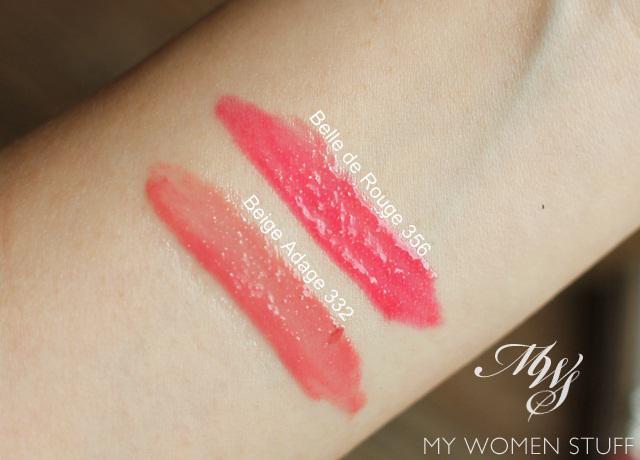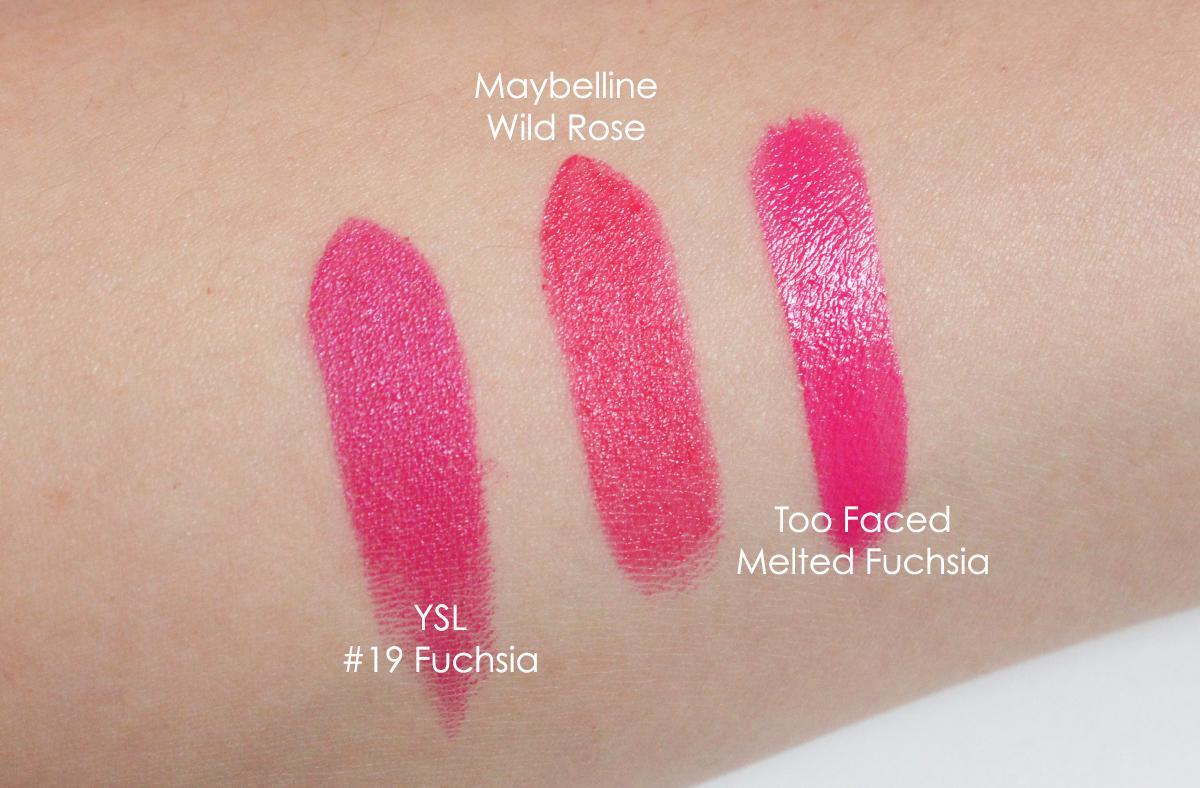The first image is the image on the left, the second image is the image on the right. Analyze the images presented: Is the assertion "One of the images does not have three stripes drawn onto skin." valid? Answer yes or no. Yes. 